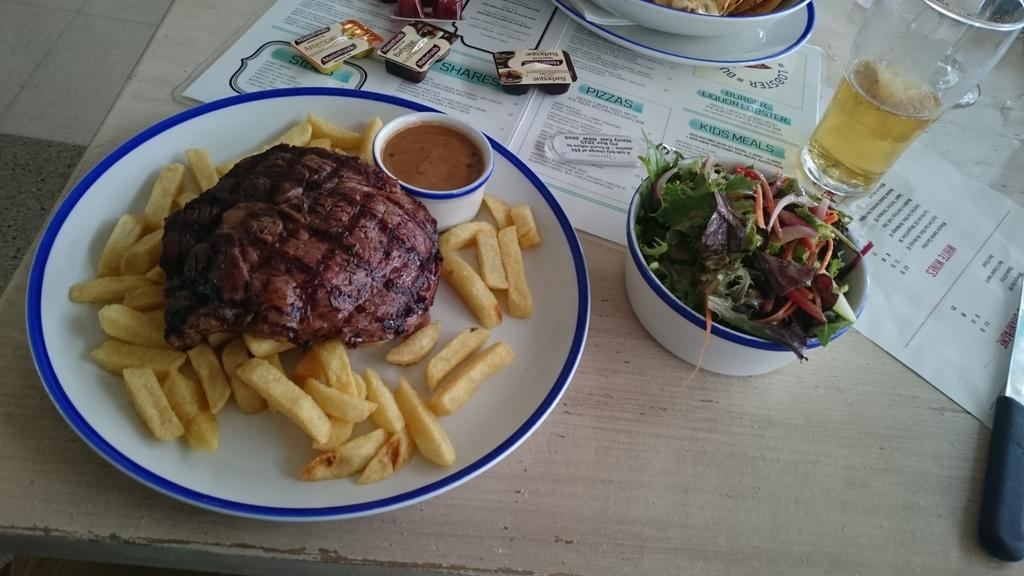What type of items can be seen in the image? There are papers, sachets, glasses, a bowl, and plates present in the image. What is contained in the bowl and plates? Food items are present in the bowl and plates. Where was the image taken? The image was taken in a room. What type of loss is depicted in the image? There is no depiction of loss in the image; it features papers, sachets, glasses, a bowl, and plates with food items. How does the growth of the plants contribute to the image? There are no plants present in the image, so growth does not contribute to the image. 